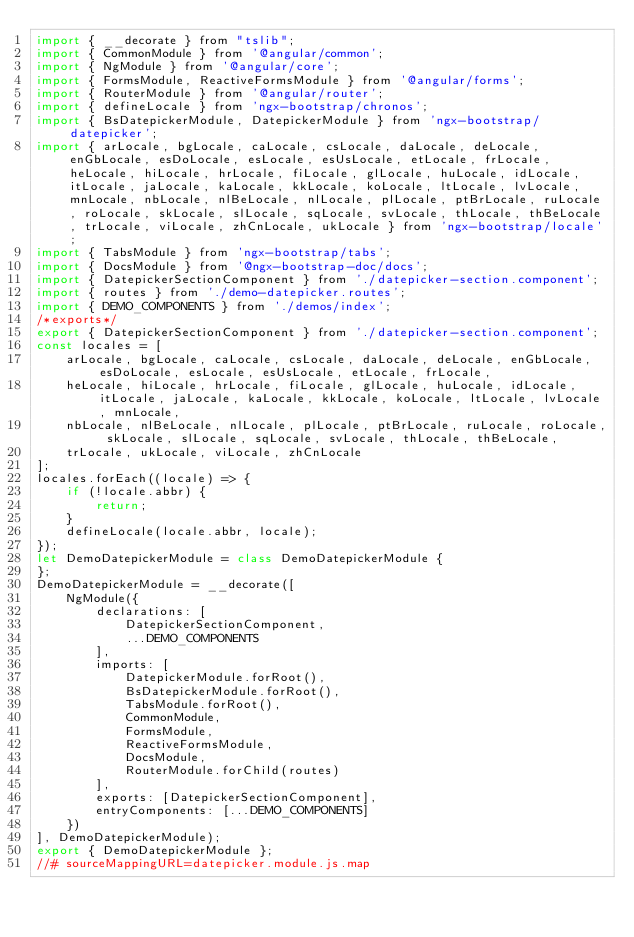<code> <loc_0><loc_0><loc_500><loc_500><_JavaScript_>import { __decorate } from "tslib";
import { CommonModule } from '@angular/common';
import { NgModule } from '@angular/core';
import { FormsModule, ReactiveFormsModule } from '@angular/forms';
import { RouterModule } from '@angular/router';
import { defineLocale } from 'ngx-bootstrap/chronos';
import { BsDatepickerModule, DatepickerModule } from 'ngx-bootstrap/datepicker';
import { arLocale, bgLocale, caLocale, csLocale, daLocale, deLocale, enGbLocale, esDoLocale, esLocale, esUsLocale, etLocale, frLocale, heLocale, hiLocale, hrLocale, fiLocale, glLocale, huLocale, idLocale, itLocale, jaLocale, kaLocale, kkLocale, koLocale, ltLocale, lvLocale, mnLocale, nbLocale, nlBeLocale, nlLocale, plLocale, ptBrLocale, ruLocale, roLocale, skLocale, slLocale, sqLocale, svLocale, thLocale, thBeLocale, trLocale, viLocale, zhCnLocale, ukLocale } from 'ngx-bootstrap/locale';
import { TabsModule } from 'ngx-bootstrap/tabs';
import { DocsModule } from '@ngx-bootstrap-doc/docs';
import { DatepickerSectionComponent } from './datepicker-section.component';
import { routes } from './demo-datepicker.routes';
import { DEMO_COMPONENTS } from './demos/index';
/*exports*/
export { DatepickerSectionComponent } from './datepicker-section.component';
const locales = [
    arLocale, bgLocale, caLocale, csLocale, daLocale, deLocale, enGbLocale, esDoLocale, esLocale, esUsLocale, etLocale, frLocale,
    heLocale, hiLocale, hrLocale, fiLocale, glLocale, huLocale, idLocale, itLocale, jaLocale, kaLocale, kkLocale, koLocale, ltLocale, lvLocale, mnLocale,
    nbLocale, nlBeLocale, nlLocale, plLocale, ptBrLocale, ruLocale, roLocale, skLocale, slLocale, sqLocale, svLocale, thLocale, thBeLocale,
    trLocale, ukLocale, viLocale, zhCnLocale
];
locales.forEach((locale) => {
    if (!locale.abbr) {
        return;
    }
    defineLocale(locale.abbr, locale);
});
let DemoDatepickerModule = class DemoDatepickerModule {
};
DemoDatepickerModule = __decorate([
    NgModule({
        declarations: [
            DatepickerSectionComponent,
            ...DEMO_COMPONENTS
        ],
        imports: [
            DatepickerModule.forRoot(),
            BsDatepickerModule.forRoot(),
            TabsModule.forRoot(),
            CommonModule,
            FormsModule,
            ReactiveFormsModule,
            DocsModule,
            RouterModule.forChild(routes)
        ],
        exports: [DatepickerSectionComponent],
        entryComponents: [...DEMO_COMPONENTS]
    })
], DemoDatepickerModule);
export { DemoDatepickerModule };
//# sourceMappingURL=datepicker.module.js.map</code> 